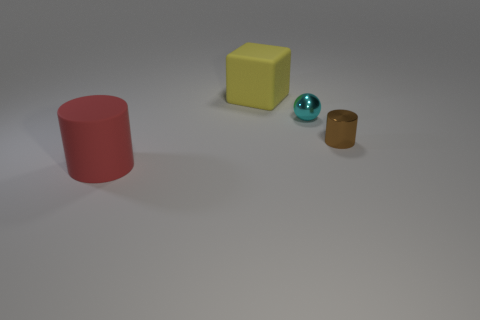Is there any other thing that has the same shape as the yellow object?
Provide a succinct answer. No. Does the large red object have the same shape as the big yellow thing?
Ensure brevity in your answer.  No. What is the red object made of?
Provide a short and direct response. Rubber. How many cylinders are behind the big cylinder and to the left of the brown cylinder?
Give a very brief answer. 0. Does the cyan shiny ball have the same size as the yellow block?
Give a very brief answer. No. Does the object behind the cyan ball have the same size as the tiny cyan ball?
Your answer should be compact. No. There is a matte thing that is in front of the large yellow block; what is its color?
Your answer should be very brief. Red. How many shiny balls are there?
Keep it short and to the point. 1. What is the shape of the thing that is made of the same material as the sphere?
Offer a terse response. Cylinder. Does the matte object that is behind the cyan thing have the same color as the cylinder behind the large red cylinder?
Give a very brief answer. No. 